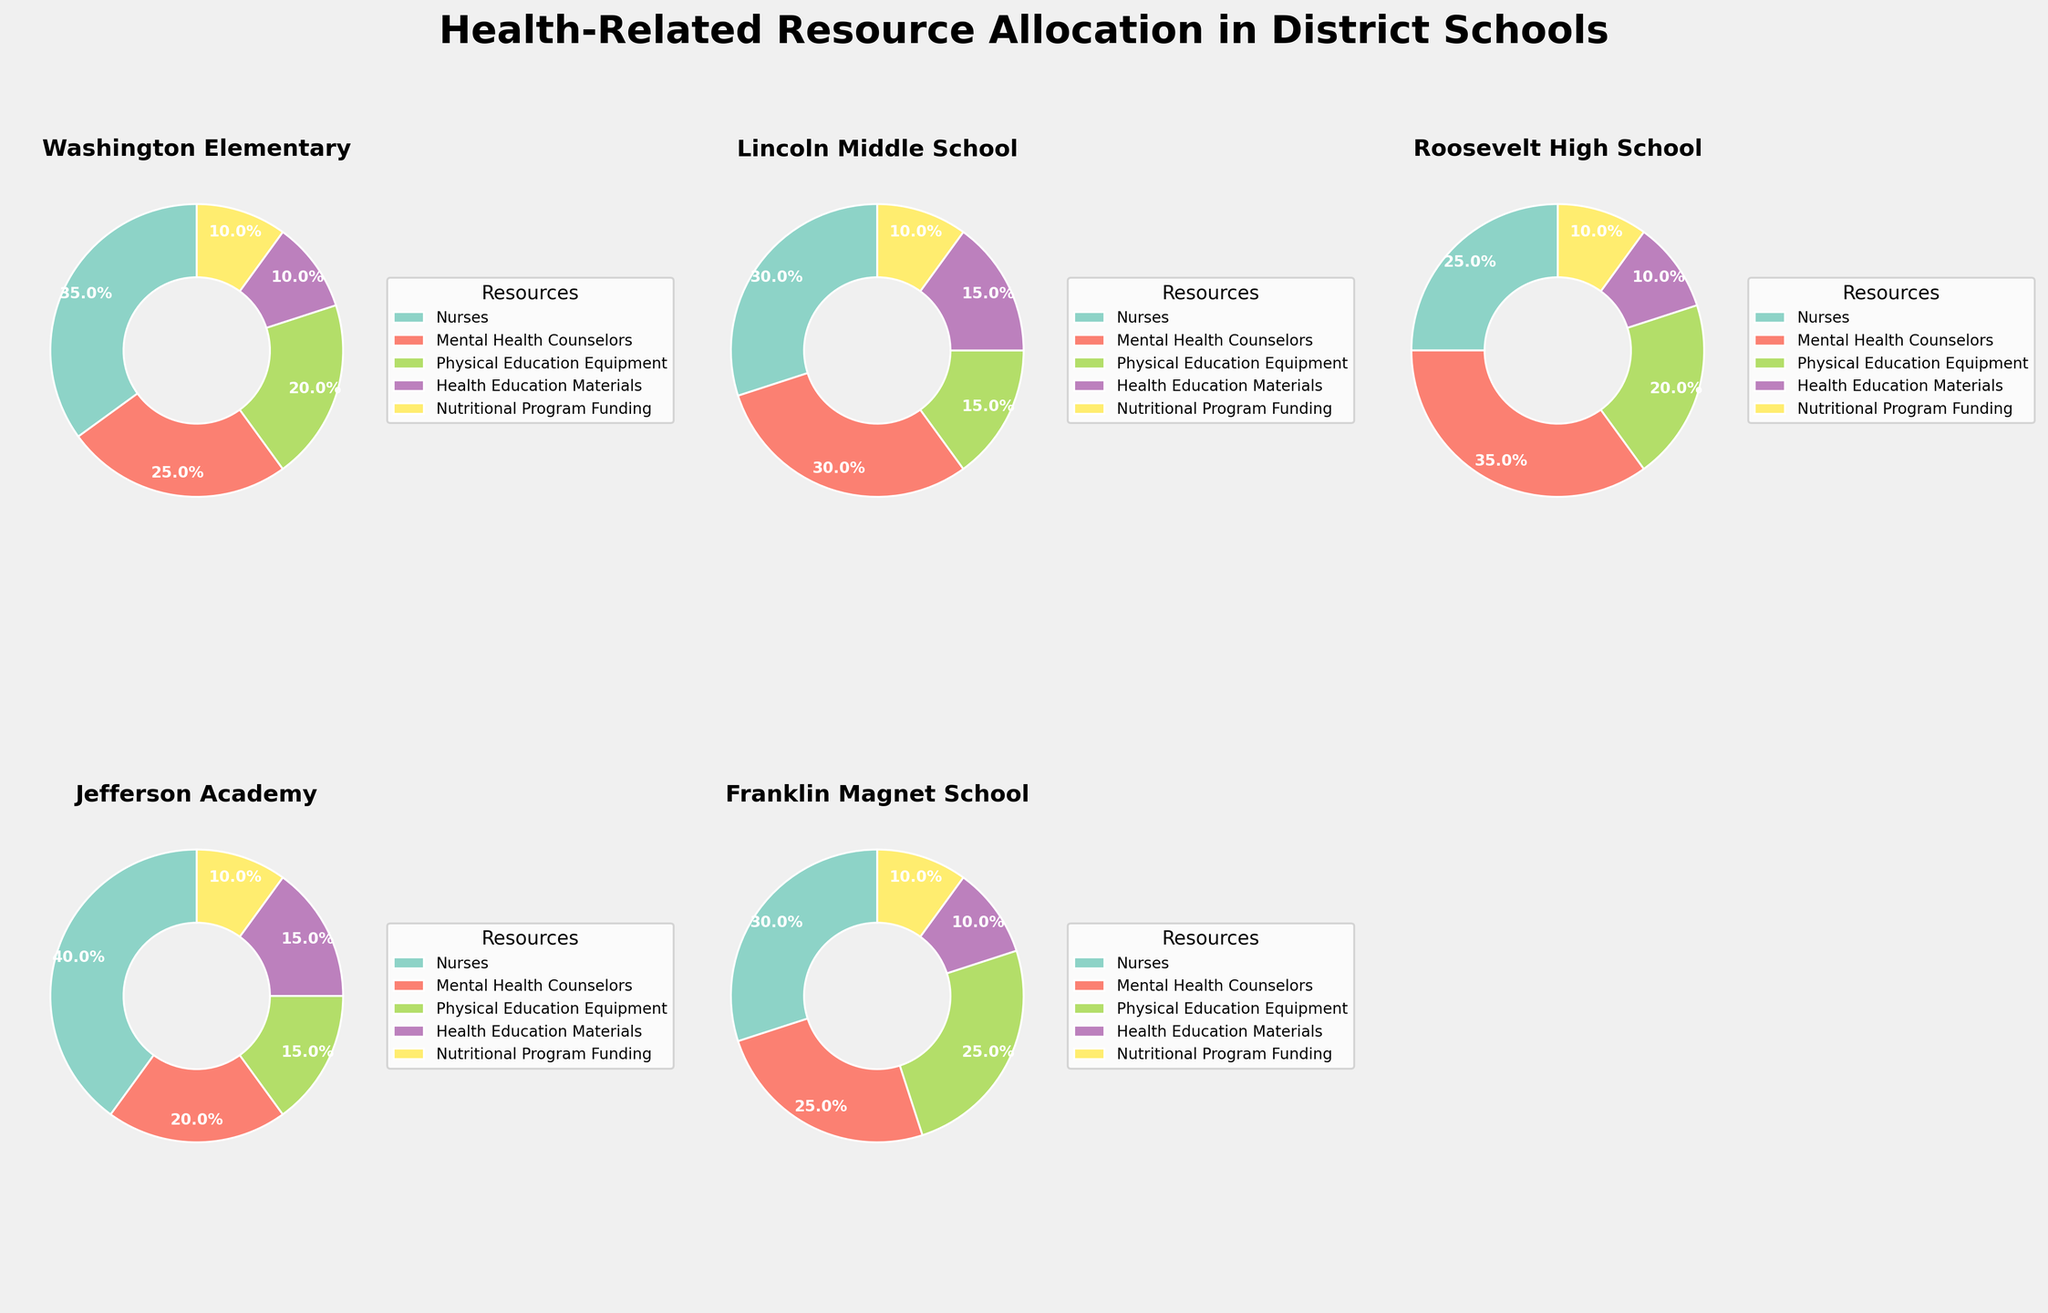What is the title of the figure? The title of the figure is displayed at the top and provides a brief description of the main topic represented in the figure.
Answer: Health-Related Resource Allocation in District Schools Which school allocated the highest percentage of resources to Nurses? To answer this, you need to look at the pie chart wedges labeled 'Nurses' in each subplot and determine which one is the largest.
Answer: Jefferson Academy Which two resources have the exact same percentage allocation in Lincoln Middle School's chart? By examining the pie chart for Lincoln Middle School, look for slices that have the same percentage value.
Answer: Mental Health Counselors and Health Education Materials What is the total percentage of resources allocated to 'Nurses' and 'Physical Education Equipment' in Roosevelt High School? To find this, add the percentage values of 'Nurses' and 'Physical Education Equipment' from Roosevelt High School's pie chart.
Answer: 45% How does the allocation for 'Nutritional Program Funding' compare across different schools? This requires comparing the size of the pie chart slices for 'Nutritional Program Funding' across all subplots.
Answer: It is 10% in all schools Which school has the least diversified allocation of health-related resources? Look for the school whose pie chart has the most similar-sized slices or the largest discrepancy between slice sizes.
Answer: Jefferson Academy If you average the percentage allocations for 'Mental Health Counselors' across all schools, what is the result? Sum the percentage values for 'Mental Health Counselors' from all schools and divide by the number of schools (5).
Answer: 27% Compare the allocation for 'Physical Education Equipment' between Washington Elementary and Franklin Magnet School. Which school allocates a higher percentage? Look at the pie slices for 'Physical Education Equipment' in both schools and determine which is larger.
Answer: Franklin Magnet School What percentage of resources did Franklin Magnet School allocate to 'Physical Education Equipment'? Check the specific pie chart for Franklin Magnet School and identify the slice for 'Physical Education Equipment'.
Answer: 25% Which resource shows the most uniform percentage allocation across all schools? By comparing the same resource slice across all subplots, identify the one with the least variation in size.
Answer: Nutritional Program Funding 